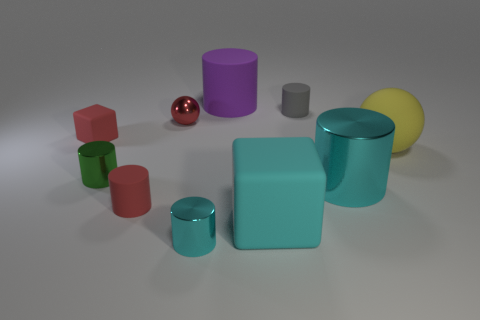Is the number of metal balls behind the small cyan shiny thing greater than the number of tiny blue metallic blocks?
Provide a short and direct response. Yes. There is a tiny sphere; are there any big purple objects left of it?
Offer a terse response. No. Is the size of the green shiny thing the same as the yellow sphere?
Keep it short and to the point. No. What is the size of the other thing that is the same shape as the large cyan matte object?
Your answer should be compact. Small. Is there any other thing that has the same size as the purple cylinder?
Your response must be concise. Yes. What is the material of the big cylinder left of the large cylinder that is right of the purple cylinder?
Make the answer very short. Rubber. Is the gray thing the same shape as the yellow matte object?
Ensure brevity in your answer.  No. How many shiny objects are both in front of the red cylinder and behind the tiny cube?
Offer a terse response. 0. Are there the same number of cyan cylinders behind the small shiny ball and large purple matte cylinders that are to the right of the big yellow matte ball?
Keep it short and to the point. Yes. Does the shiny object that is behind the big yellow matte sphere have the same size as the block that is behind the small red matte cylinder?
Ensure brevity in your answer.  Yes. 